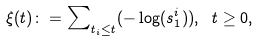Convert formula to latex. <formula><loc_0><loc_0><loc_500><loc_500>\xi ( t ) \colon = \sum \nolimits _ { t _ { i } \leq t } ( - \log ( s _ { 1 } ^ { i } ) ) , \text { } t \geq 0 ,</formula> 